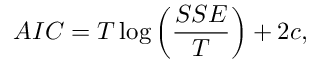<formula> <loc_0><loc_0><loc_500><loc_500>A I C = T \log \left ( \frac { S S E } { T } \right ) + 2 c ,</formula> 